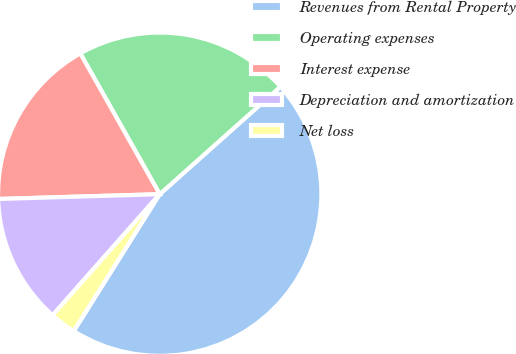Convert chart to OTSL. <chart><loc_0><loc_0><loc_500><loc_500><pie_chart><fcel>Revenues from Rental Property<fcel>Operating expenses<fcel>Interest expense<fcel>Depreciation and amortization<fcel>Net loss<nl><fcel>45.51%<fcel>21.59%<fcel>17.3%<fcel>13.0%<fcel>2.6%<nl></chart> 